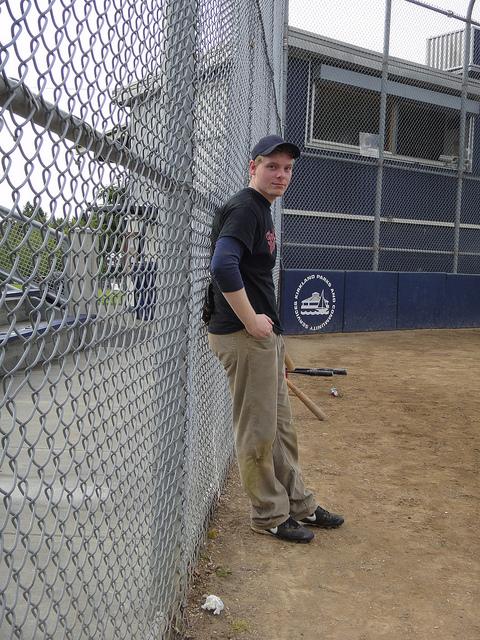What game is the equipment in the background for?
Give a very brief answer. Baseball. What is the white thing on the ground in the forefront?
Give a very brief answer. Trash. What type of fence is the man leaning on?
Write a very short answer. Chain link. 